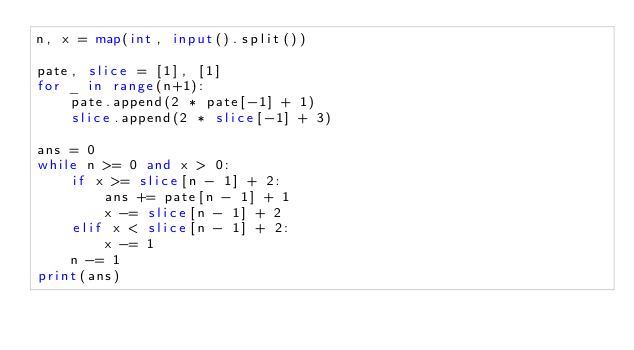<code> <loc_0><loc_0><loc_500><loc_500><_Python_>n, x = map(int, input().split())

pate, slice = [1], [1]
for _ in range(n+1):
    pate.append(2 * pate[-1] + 1)
    slice.append(2 * slice[-1] + 3)

ans = 0
while n >= 0 and x > 0:
    if x >= slice[n - 1] + 2:
        ans += pate[n - 1] + 1
        x -= slice[n - 1] + 2
    elif x < slice[n - 1] + 2:
        x -= 1
    n -= 1
print(ans)
</code> 